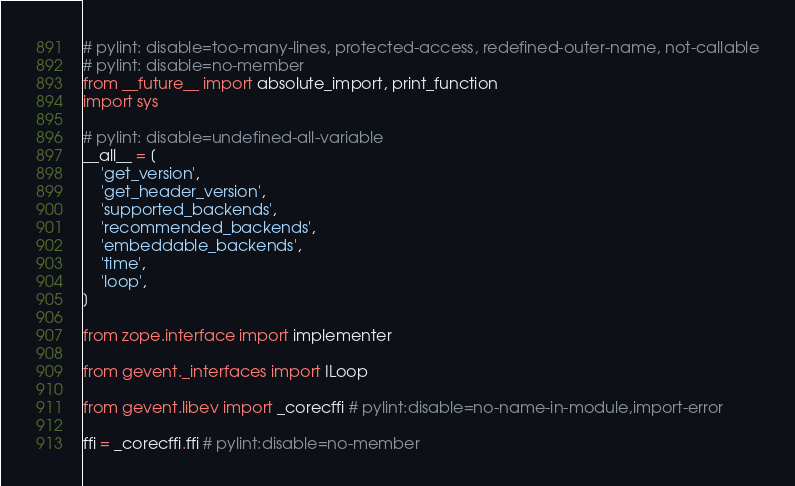Convert code to text. <code><loc_0><loc_0><loc_500><loc_500><_Python_># pylint: disable=too-many-lines, protected-access, redefined-outer-name, not-callable
# pylint: disable=no-member
from __future__ import absolute_import, print_function
import sys

# pylint: disable=undefined-all-variable
__all__ = [
    'get_version',
    'get_header_version',
    'supported_backends',
    'recommended_backends',
    'embeddable_backends',
    'time',
    'loop',
]

from zope.interface import implementer

from gevent._interfaces import ILoop

from gevent.libev import _corecffi # pylint:disable=no-name-in-module,import-error

ffi = _corecffi.ffi # pylint:disable=no-member</code> 